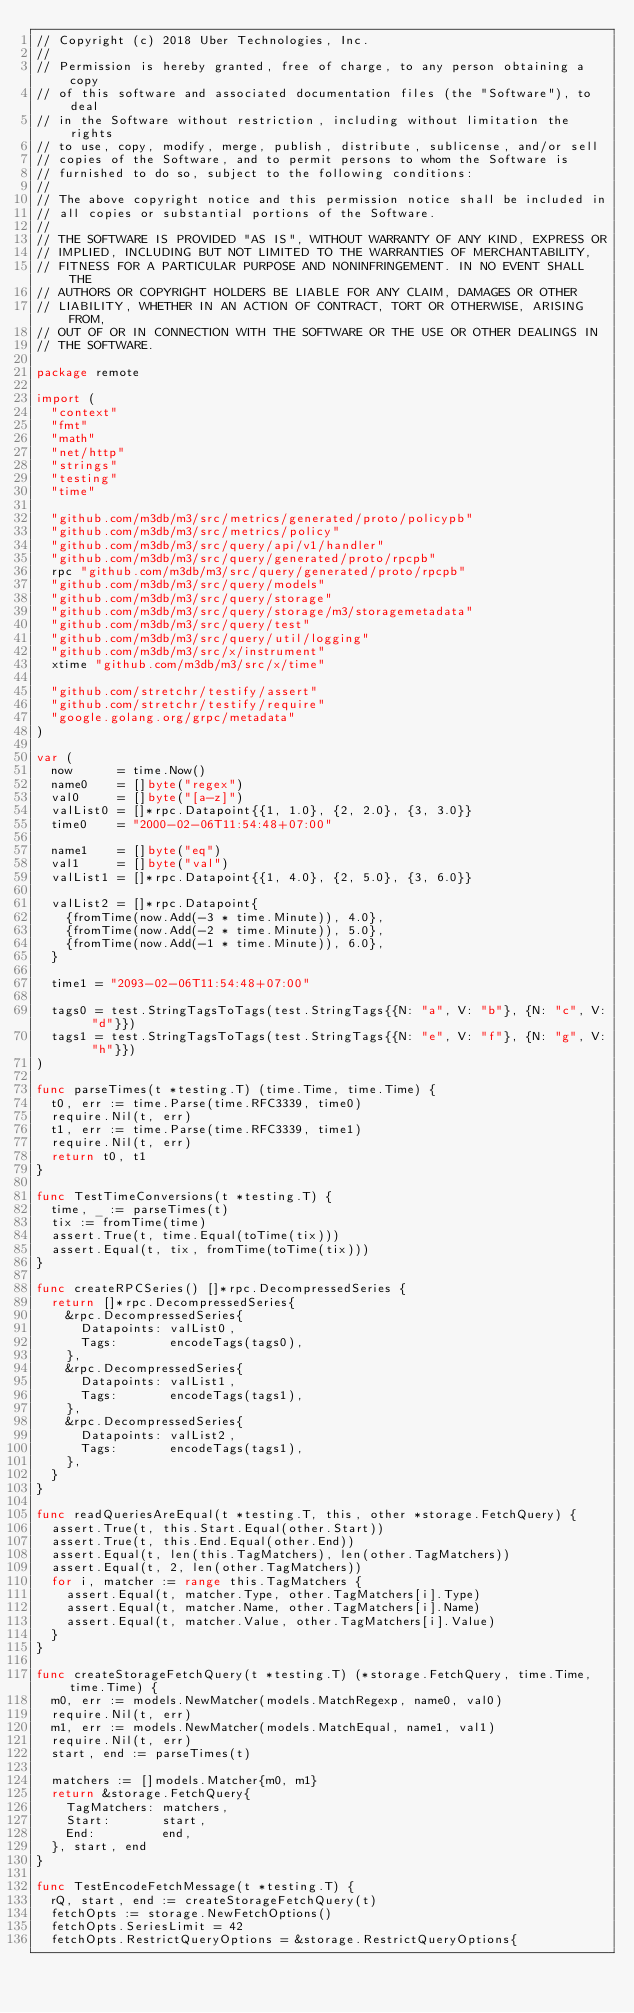Convert code to text. <code><loc_0><loc_0><loc_500><loc_500><_Go_>// Copyright (c) 2018 Uber Technologies, Inc.
//
// Permission is hereby granted, free of charge, to any person obtaining a copy
// of this software and associated documentation files (the "Software"), to deal
// in the Software without restriction, including without limitation the rights
// to use, copy, modify, merge, publish, distribute, sublicense, and/or sell
// copies of the Software, and to permit persons to whom the Software is
// furnished to do so, subject to the following conditions:
//
// The above copyright notice and this permission notice shall be included in
// all copies or substantial portions of the Software.
//
// THE SOFTWARE IS PROVIDED "AS IS", WITHOUT WARRANTY OF ANY KIND, EXPRESS OR
// IMPLIED, INCLUDING BUT NOT LIMITED TO THE WARRANTIES OF MERCHANTABILITY,
// FITNESS FOR A PARTICULAR PURPOSE AND NONINFRINGEMENT. IN NO EVENT SHALL THE
// AUTHORS OR COPYRIGHT HOLDERS BE LIABLE FOR ANY CLAIM, DAMAGES OR OTHER
// LIABILITY, WHETHER IN AN ACTION OF CONTRACT, TORT OR OTHERWISE, ARISING FROM,
// OUT OF OR IN CONNECTION WITH THE SOFTWARE OR THE USE OR OTHER DEALINGS IN
// THE SOFTWARE.

package remote

import (
	"context"
	"fmt"
	"math"
	"net/http"
	"strings"
	"testing"
	"time"

	"github.com/m3db/m3/src/metrics/generated/proto/policypb"
	"github.com/m3db/m3/src/metrics/policy"
	"github.com/m3db/m3/src/query/api/v1/handler"
	"github.com/m3db/m3/src/query/generated/proto/rpcpb"
	rpc "github.com/m3db/m3/src/query/generated/proto/rpcpb"
	"github.com/m3db/m3/src/query/models"
	"github.com/m3db/m3/src/query/storage"
	"github.com/m3db/m3/src/query/storage/m3/storagemetadata"
	"github.com/m3db/m3/src/query/test"
	"github.com/m3db/m3/src/query/util/logging"
	"github.com/m3db/m3/src/x/instrument"
	xtime "github.com/m3db/m3/src/x/time"

	"github.com/stretchr/testify/assert"
	"github.com/stretchr/testify/require"
	"google.golang.org/grpc/metadata"
)

var (
	now      = time.Now()
	name0    = []byte("regex")
	val0     = []byte("[a-z]")
	valList0 = []*rpc.Datapoint{{1, 1.0}, {2, 2.0}, {3, 3.0}}
	time0    = "2000-02-06T11:54:48+07:00"

	name1    = []byte("eq")
	val1     = []byte("val")
	valList1 = []*rpc.Datapoint{{1, 4.0}, {2, 5.0}, {3, 6.0}}

	valList2 = []*rpc.Datapoint{
		{fromTime(now.Add(-3 * time.Minute)), 4.0},
		{fromTime(now.Add(-2 * time.Minute)), 5.0},
		{fromTime(now.Add(-1 * time.Minute)), 6.0},
	}

	time1 = "2093-02-06T11:54:48+07:00"

	tags0 = test.StringTagsToTags(test.StringTags{{N: "a", V: "b"}, {N: "c", V: "d"}})
	tags1 = test.StringTagsToTags(test.StringTags{{N: "e", V: "f"}, {N: "g", V: "h"}})
)

func parseTimes(t *testing.T) (time.Time, time.Time) {
	t0, err := time.Parse(time.RFC3339, time0)
	require.Nil(t, err)
	t1, err := time.Parse(time.RFC3339, time1)
	require.Nil(t, err)
	return t0, t1
}

func TestTimeConversions(t *testing.T) {
	time, _ := parseTimes(t)
	tix := fromTime(time)
	assert.True(t, time.Equal(toTime(tix)))
	assert.Equal(t, tix, fromTime(toTime(tix)))
}

func createRPCSeries() []*rpc.DecompressedSeries {
	return []*rpc.DecompressedSeries{
		&rpc.DecompressedSeries{
			Datapoints: valList0,
			Tags:       encodeTags(tags0),
		},
		&rpc.DecompressedSeries{
			Datapoints: valList1,
			Tags:       encodeTags(tags1),
		},
		&rpc.DecompressedSeries{
			Datapoints: valList2,
			Tags:       encodeTags(tags1),
		},
	}
}

func readQueriesAreEqual(t *testing.T, this, other *storage.FetchQuery) {
	assert.True(t, this.Start.Equal(other.Start))
	assert.True(t, this.End.Equal(other.End))
	assert.Equal(t, len(this.TagMatchers), len(other.TagMatchers))
	assert.Equal(t, 2, len(other.TagMatchers))
	for i, matcher := range this.TagMatchers {
		assert.Equal(t, matcher.Type, other.TagMatchers[i].Type)
		assert.Equal(t, matcher.Name, other.TagMatchers[i].Name)
		assert.Equal(t, matcher.Value, other.TagMatchers[i].Value)
	}
}

func createStorageFetchQuery(t *testing.T) (*storage.FetchQuery, time.Time, time.Time) {
	m0, err := models.NewMatcher(models.MatchRegexp, name0, val0)
	require.Nil(t, err)
	m1, err := models.NewMatcher(models.MatchEqual, name1, val1)
	require.Nil(t, err)
	start, end := parseTimes(t)

	matchers := []models.Matcher{m0, m1}
	return &storage.FetchQuery{
		TagMatchers: matchers,
		Start:       start,
		End:         end,
	}, start, end
}

func TestEncodeFetchMessage(t *testing.T) {
	rQ, start, end := createStorageFetchQuery(t)
	fetchOpts := storage.NewFetchOptions()
	fetchOpts.SeriesLimit = 42
	fetchOpts.RestrictQueryOptions = &storage.RestrictQueryOptions{</code> 